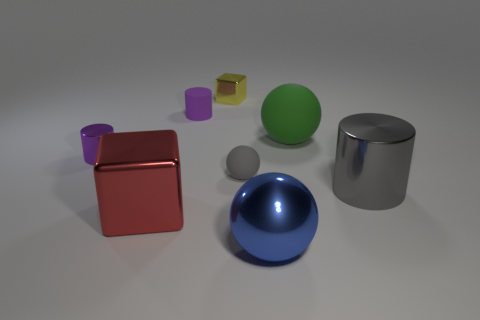Subtract all large balls. How many balls are left? 1 Add 1 large gray shiny cylinders. How many objects exist? 9 Subtract all purple cylinders. How many cylinders are left? 1 Subtract 1 red blocks. How many objects are left? 7 Subtract all cubes. How many objects are left? 6 Subtract 1 cylinders. How many cylinders are left? 2 Subtract all blue cylinders. Subtract all green balls. How many cylinders are left? 3 Subtract all cyan blocks. How many blue spheres are left? 1 Subtract all big green objects. Subtract all blocks. How many objects are left? 5 Add 8 tiny yellow things. How many tiny yellow things are left? 9 